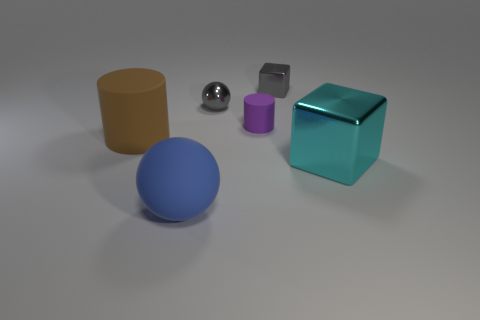Subtract all brown cylinders. How many cylinders are left? 1 Add 4 small purple matte things. How many objects exist? 10 Subtract all balls. How many objects are left? 4 Subtract 1 spheres. How many spheres are left? 1 Subtract all big green metallic balls. Subtract all cylinders. How many objects are left? 4 Add 5 spheres. How many spheres are left? 7 Add 4 gray metal spheres. How many gray metal spheres exist? 5 Subtract 0 purple spheres. How many objects are left? 6 Subtract all purple cylinders. Subtract all red blocks. How many cylinders are left? 1 